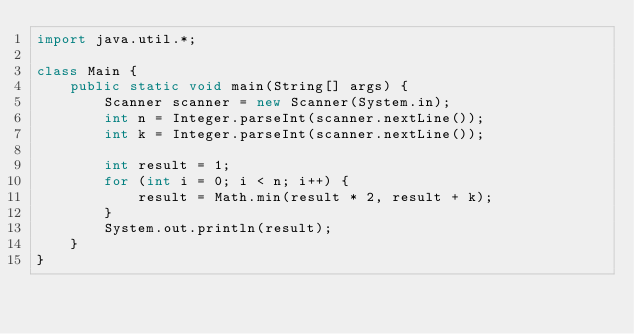<code> <loc_0><loc_0><loc_500><loc_500><_Java_>import java.util.*;

class Main {
    public static void main(String[] args) {
        Scanner scanner = new Scanner(System.in);
        int n = Integer.parseInt(scanner.nextLine());
        int k = Integer.parseInt(scanner.nextLine());

        int result = 1;
        for (int i = 0; i < n; i++) {
            result = Math.min(result * 2, result + k);
        }
        System.out.println(result);
    }
}
</code> 